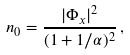Convert formula to latex. <formula><loc_0><loc_0><loc_500><loc_500>n _ { 0 } = \frac { | \Phi _ { x } | ^ { 2 } } { ( 1 + 1 / \alpha ) ^ { 2 } } \, ,</formula> 